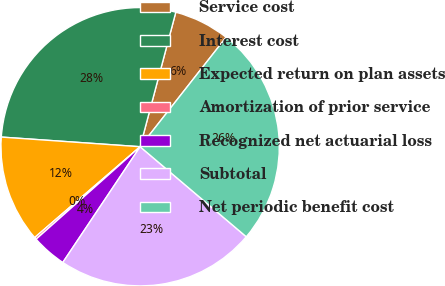<chart> <loc_0><loc_0><loc_500><loc_500><pie_chart><fcel>Service cost<fcel>Interest cost<fcel>Expected return on plan assets<fcel>Amortization of prior service<fcel>Recognized net actuarial loss<fcel>Subtotal<fcel>Net periodic benefit cost<nl><fcel>6.47%<fcel>28.02%<fcel>12.42%<fcel>0.25%<fcel>4.06%<fcel>23.18%<fcel>25.6%<nl></chart> 